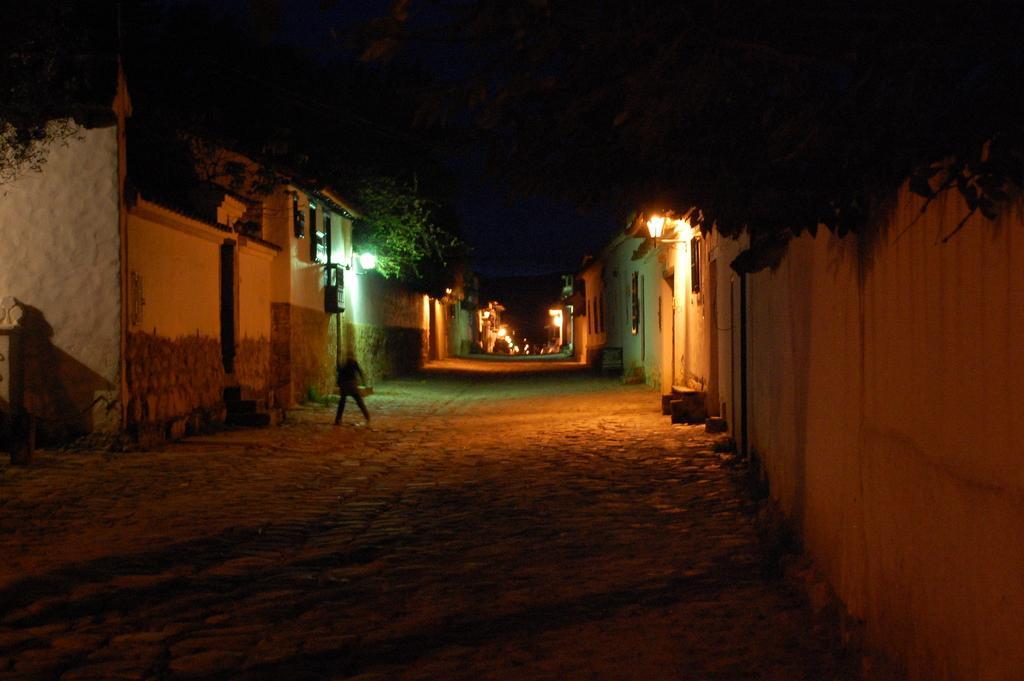Could you give a brief overview of what you see in this image? In this image I can see a houses,windows and lights. I can see trees and a wall. 